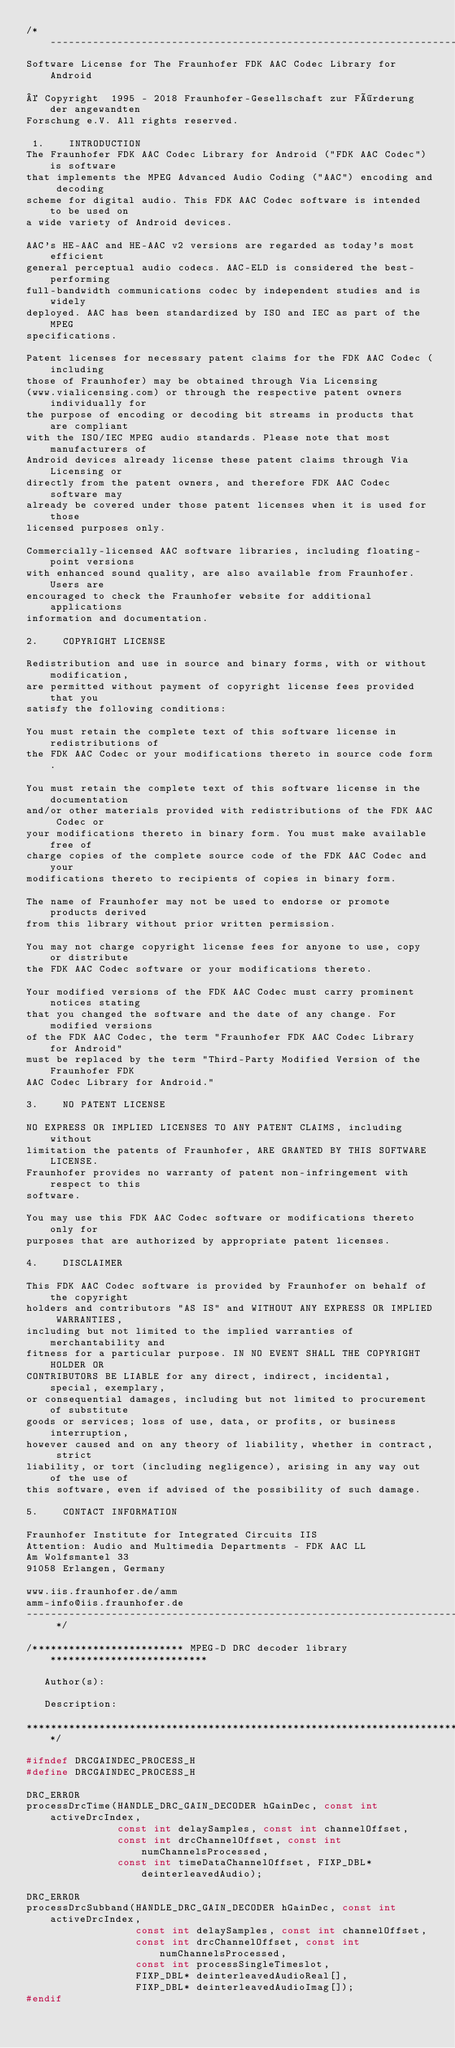Convert code to text. <code><loc_0><loc_0><loc_500><loc_500><_C_>/* -----------------------------------------------------------------------------
Software License for The Fraunhofer FDK AAC Codec Library for Android

© Copyright  1995 - 2018 Fraunhofer-Gesellschaft zur Förderung der angewandten
Forschung e.V. All rights reserved.

 1.    INTRODUCTION
The Fraunhofer FDK AAC Codec Library for Android ("FDK AAC Codec") is software
that implements the MPEG Advanced Audio Coding ("AAC") encoding and decoding
scheme for digital audio. This FDK AAC Codec software is intended to be used on
a wide variety of Android devices.

AAC's HE-AAC and HE-AAC v2 versions are regarded as today's most efficient
general perceptual audio codecs. AAC-ELD is considered the best-performing
full-bandwidth communications codec by independent studies and is widely
deployed. AAC has been standardized by ISO and IEC as part of the MPEG
specifications.

Patent licenses for necessary patent claims for the FDK AAC Codec (including
those of Fraunhofer) may be obtained through Via Licensing
(www.vialicensing.com) or through the respective patent owners individually for
the purpose of encoding or decoding bit streams in products that are compliant
with the ISO/IEC MPEG audio standards. Please note that most manufacturers of
Android devices already license these patent claims through Via Licensing or
directly from the patent owners, and therefore FDK AAC Codec software may
already be covered under those patent licenses when it is used for those
licensed purposes only.

Commercially-licensed AAC software libraries, including floating-point versions
with enhanced sound quality, are also available from Fraunhofer. Users are
encouraged to check the Fraunhofer website for additional applications
information and documentation.

2.    COPYRIGHT LICENSE

Redistribution and use in source and binary forms, with or without modification,
are permitted without payment of copyright license fees provided that you
satisfy the following conditions:

You must retain the complete text of this software license in redistributions of
the FDK AAC Codec or your modifications thereto in source code form.

You must retain the complete text of this software license in the documentation
and/or other materials provided with redistributions of the FDK AAC Codec or
your modifications thereto in binary form. You must make available free of
charge copies of the complete source code of the FDK AAC Codec and your
modifications thereto to recipients of copies in binary form.

The name of Fraunhofer may not be used to endorse or promote products derived
from this library without prior written permission.

You may not charge copyright license fees for anyone to use, copy or distribute
the FDK AAC Codec software or your modifications thereto.

Your modified versions of the FDK AAC Codec must carry prominent notices stating
that you changed the software and the date of any change. For modified versions
of the FDK AAC Codec, the term "Fraunhofer FDK AAC Codec Library for Android"
must be replaced by the term "Third-Party Modified Version of the Fraunhofer FDK
AAC Codec Library for Android."

3.    NO PATENT LICENSE

NO EXPRESS OR IMPLIED LICENSES TO ANY PATENT CLAIMS, including without
limitation the patents of Fraunhofer, ARE GRANTED BY THIS SOFTWARE LICENSE.
Fraunhofer provides no warranty of patent non-infringement with respect to this
software.

You may use this FDK AAC Codec software or modifications thereto only for
purposes that are authorized by appropriate patent licenses.

4.    DISCLAIMER

This FDK AAC Codec software is provided by Fraunhofer on behalf of the copyright
holders and contributors "AS IS" and WITHOUT ANY EXPRESS OR IMPLIED WARRANTIES,
including but not limited to the implied warranties of merchantability and
fitness for a particular purpose. IN NO EVENT SHALL THE COPYRIGHT HOLDER OR
CONTRIBUTORS BE LIABLE for any direct, indirect, incidental, special, exemplary,
or consequential damages, including but not limited to procurement of substitute
goods or services; loss of use, data, or profits, or business interruption,
however caused and on any theory of liability, whether in contract, strict
liability, or tort (including negligence), arising in any way out of the use of
this software, even if advised of the possibility of such damage.

5.    CONTACT INFORMATION

Fraunhofer Institute for Integrated Circuits IIS
Attention: Audio and Multimedia Departments - FDK AAC LL
Am Wolfsmantel 33
91058 Erlangen, Germany

www.iis.fraunhofer.de/amm
amm-info@iis.fraunhofer.de
----------------------------------------------------------------------------- */

/************************* MPEG-D DRC decoder library **************************

   Author(s):

   Description:

*******************************************************************************/

#ifndef DRCGAINDEC_PROCESS_H
#define DRCGAINDEC_PROCESS_H

DRC_ERROR
processDrcTime(HANDLE_DRC_GAIN_DECODER hGainDec, const int activeDrcIndex,
               const int delaySamples, const int channelOffset,
               const int drcChannelOffset, const int numChannelsProcessed,
               const int timeDataChannelOffset, FIXP_DBL* deinterleavedAudio);

DRC_ERROR
processDrcSubband(HANDLE_DRC_GAIN_DECODER hGainDec, const int activeDrcIndex,
                  const int delaySamples, const int channelOffset,
                  const int drcChannelOffset, const int numChannelsProcessed,
                  const int processSingleTimeslot,
                  FIXP_DBL* deinterleavedAudioReal[],
                  FIXP_DBL* deinterleavedAudioImag[]);
#endif
</code> 